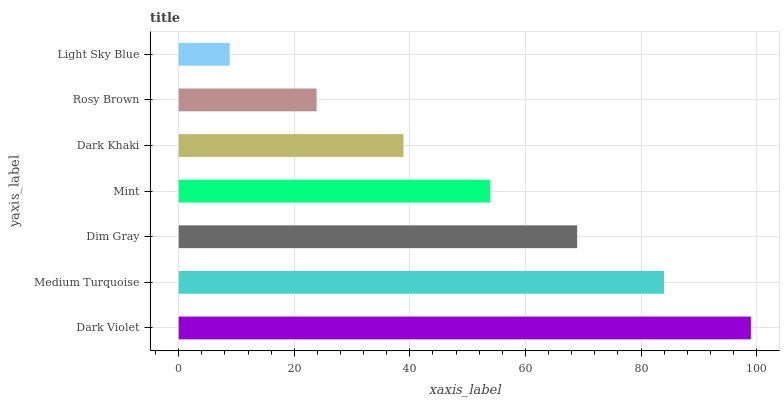Is Light Sky Blue the minimum?
Answer yes or no. Yes. Is Dark Violet the maximum?
Answer yes or no. Yes. Is Medium Turquoise the minimum?
Answer yes or no. No. Is Medium Turquoise the maximum?
Answer yes or no. No. Is Dark Violet greater than Medium Turquoise?
Answer yes or no. Yes. Is Medium Turquoise less than Dark Violet?
Answer yes or no. Yes. Is Medium Turquoise greater than Dark Violet?
Answer yes or no. No. Is Dark Violet less than Medium Turquoise?
Answer yes or no. No. Is Mint the high median?
Answer yes or no. Yes. Is Mint the low median?
Answer yes or no. Yes. Is Rosy Brown the high median?
Answer yes or no. No. Is Dim Gray the low median?
Answer yes or no. No. 